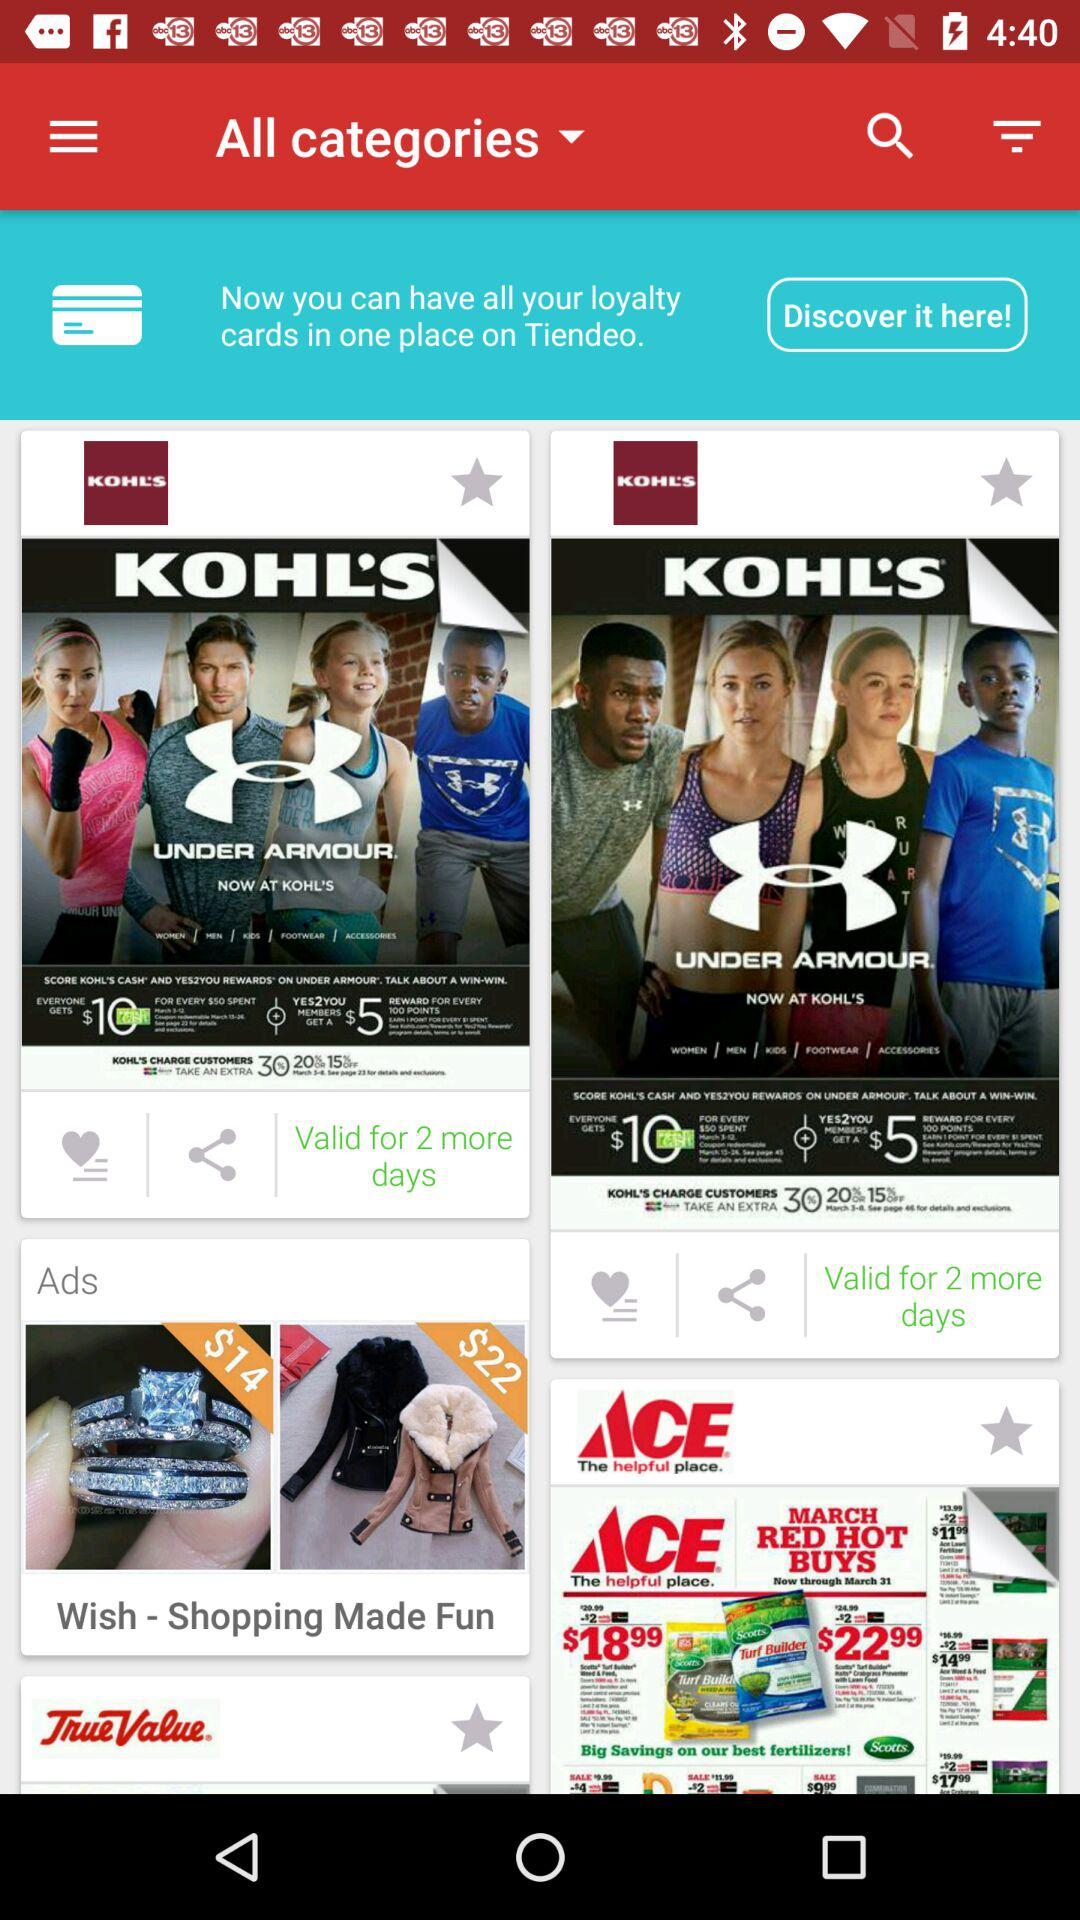For how many days is the offer valid? The offer is valid for 2 more days. 